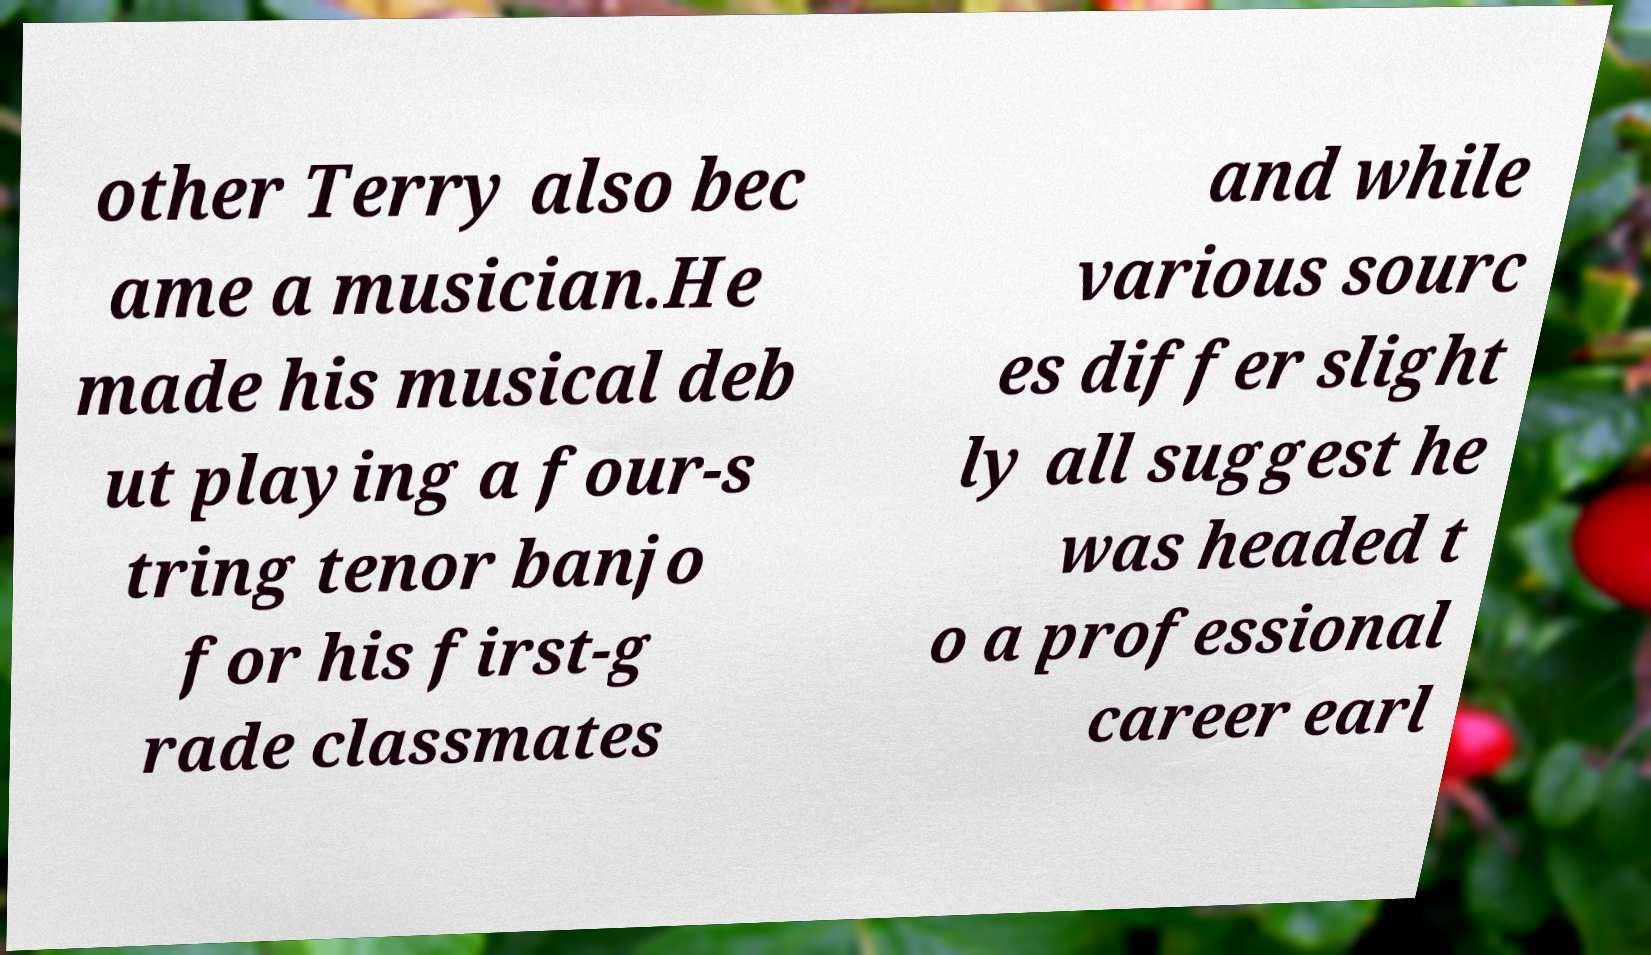Can you read and provide the text displayed in the image?This photo seems to have some interesting text. Can you extract and type it out for me? other Terry also bec ame a musician.He made his musical deb ut playing a four-s tring tenor banjo for his first-g rade classmates and while various sourc es differ slight ly all suggest he was headed t o a professional career earl 